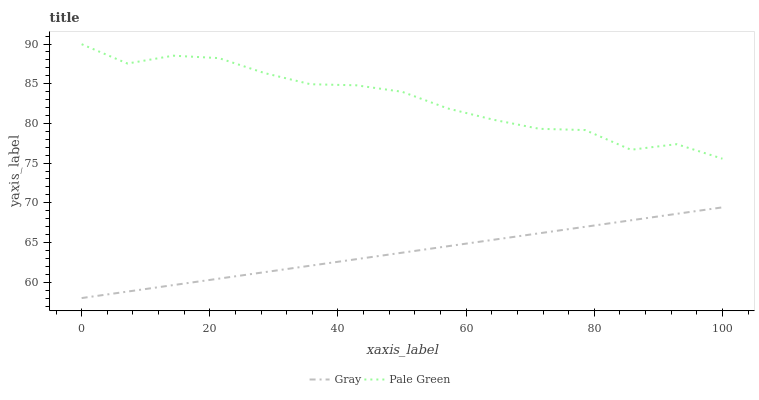Does Gray have the minimum area under the curve?
Answer yes or no. Yes. Does Pale Green have the maximum area under the curve?
Answer yes or no. Yes. Does Pale Green have the minimum area under the curve?
Answer yes or no. No. Is Gray the smoothest?
Answer yes or no. Yes. Is Pale Green the roughest?
Answer yes or no. Yes. Is Pale Green the smoothest?
Answer yes or no. No. Does Pale Green have the lowest value?
Answer yes or no. No. Does Pale Green have the highest value?
Answer yes or no. Yes. Is Gray less than Pale Green?
Answer yes or no. Yes. Is Pale Green greater than Gray?
Answer yes or no. Yes. Does Gray intersect Pale Green?
Answer yes or no. No. 